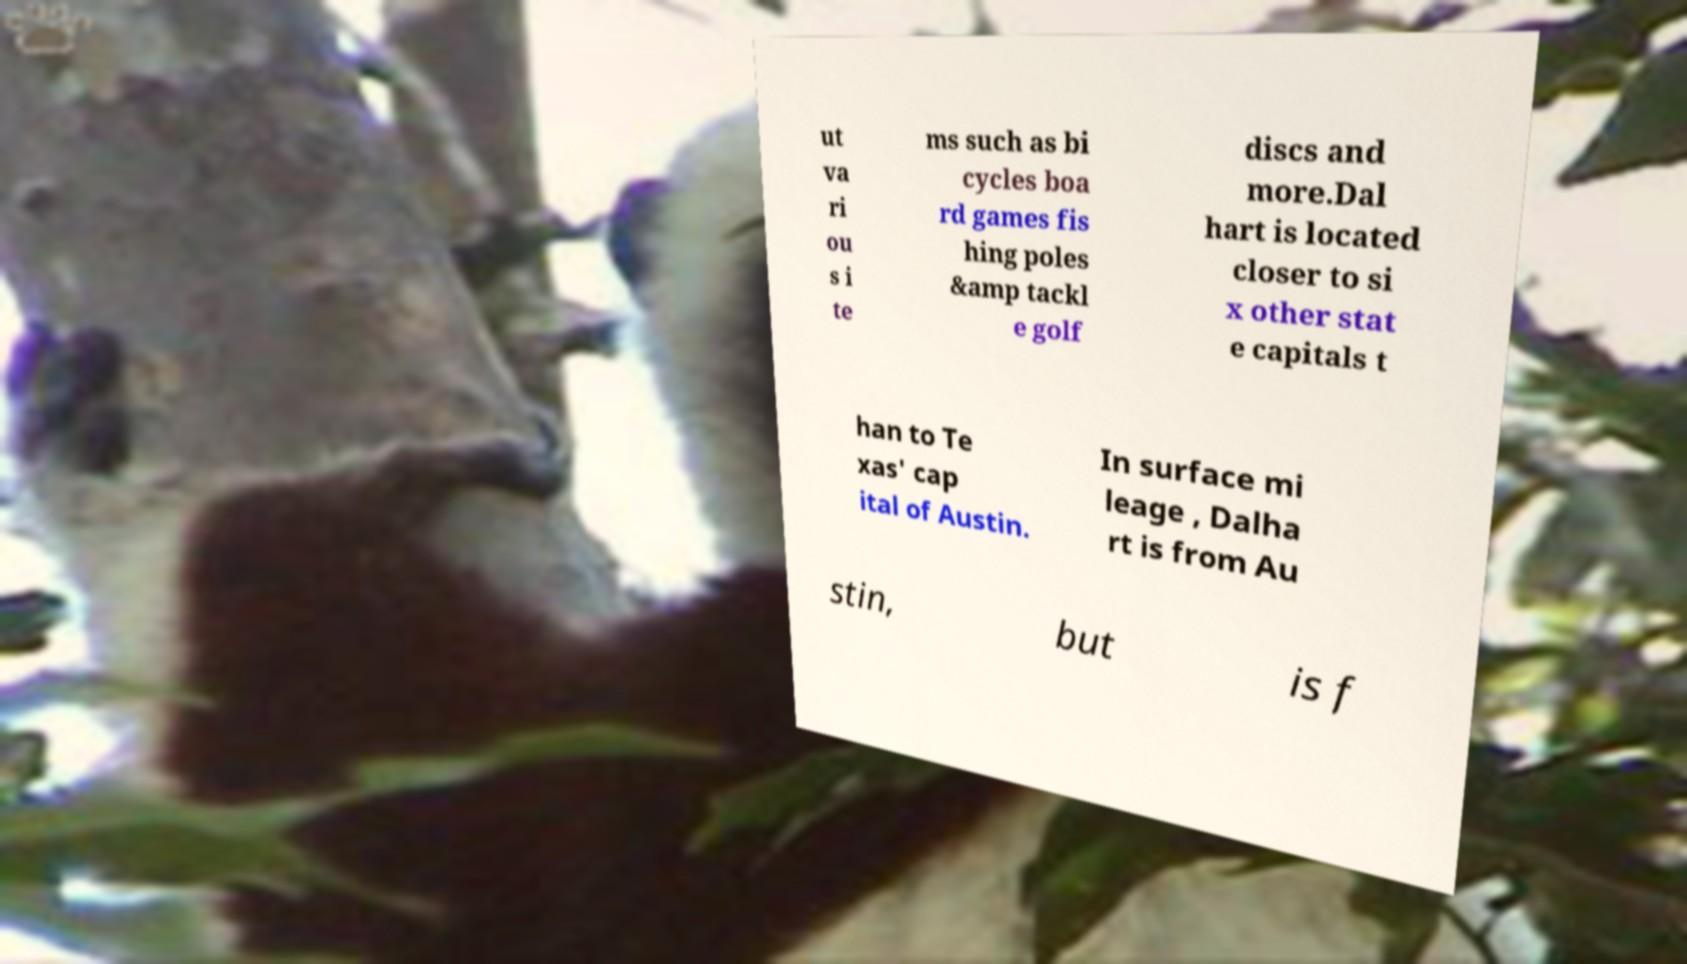What messages or text are displayed in this image? I need them in a readable, typed format. ut va ri ou s i te ms such as bi cycles boa rd games fis hing poles &amp tackl e golf discs and more.Dal hart is located closer to si x other stat e capitals t han to Te xas' cap ital of Austin. In surface mi leage , Dalha rt is from Au stin, but is f 